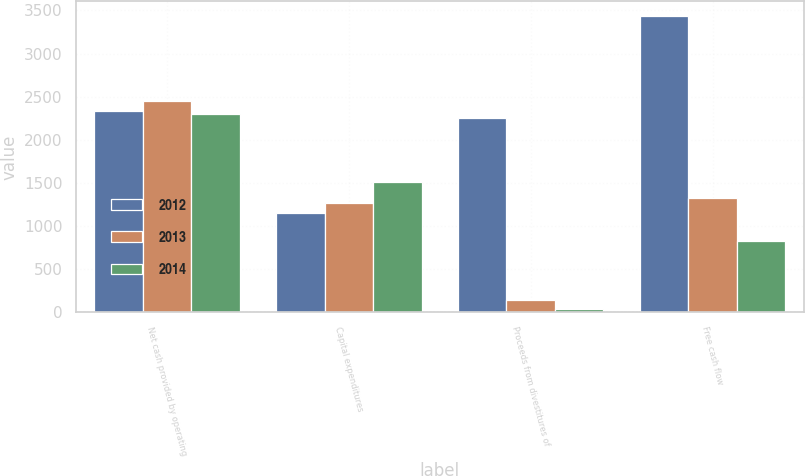<chart> <loc_0><loc_0><loc_500><loc_500><stacked_bar_chart><ecel><fcel>Net cash provided by operating<fcel>Capital expenditures<fcel>Proceeds from divestitures of<fcel>Free cash flow<nl><fcel>2012<fcel>2331<fcel>1151<fcel>2253<fcel>3433<nl><fcel>2013<fcel>2455<fcel>1271<fcel>138<fcel>1322<nl><fcel>2014<fcel>2295<fcel>1510<fcel>44<fcel>829<nl></chart> 